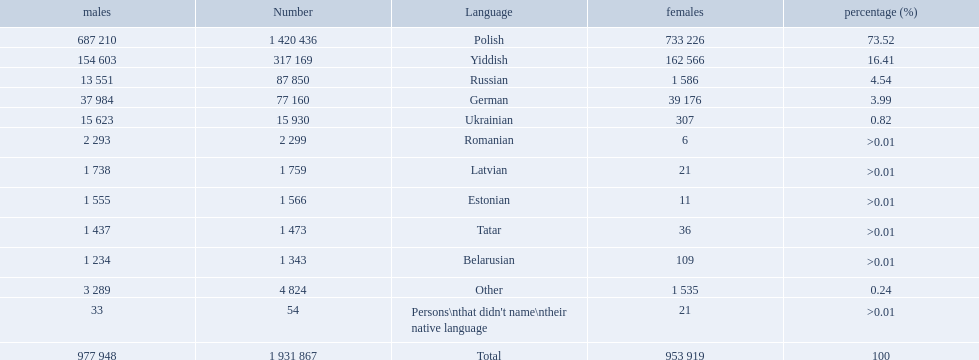What were all the languages? Polish, Yiddish, Russian, German, Ukrainian, Romanian, Latvian, Estonian, Tatar, Belarusian, Other, Persons\nthat didn't name\ntheir native language. For these, how many people spoke them? 1 420 436, 317 169, 87 850, 77 160, 15 930, 2 299, 1 759, 1 566, 1 473, 1 343, 4 824, 54. Of these, which is the largest number of speakers? 1 420 436. Which language corresponds to this number? Polish. 